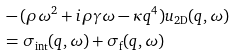<formula> <loc_0><loc_0><loc_500><loc_500>& - ( \rho \omega ^ { 2 } + i \rho \gamma \omega - \kappa q ^ { 4 } ) u _ { \text {2D} } ( q , \omega ) \\ & = \sigma _ { \text {int} } ( q , \omega ) + \sigma _ { \text {f} } ( q , \omega )</formula> 